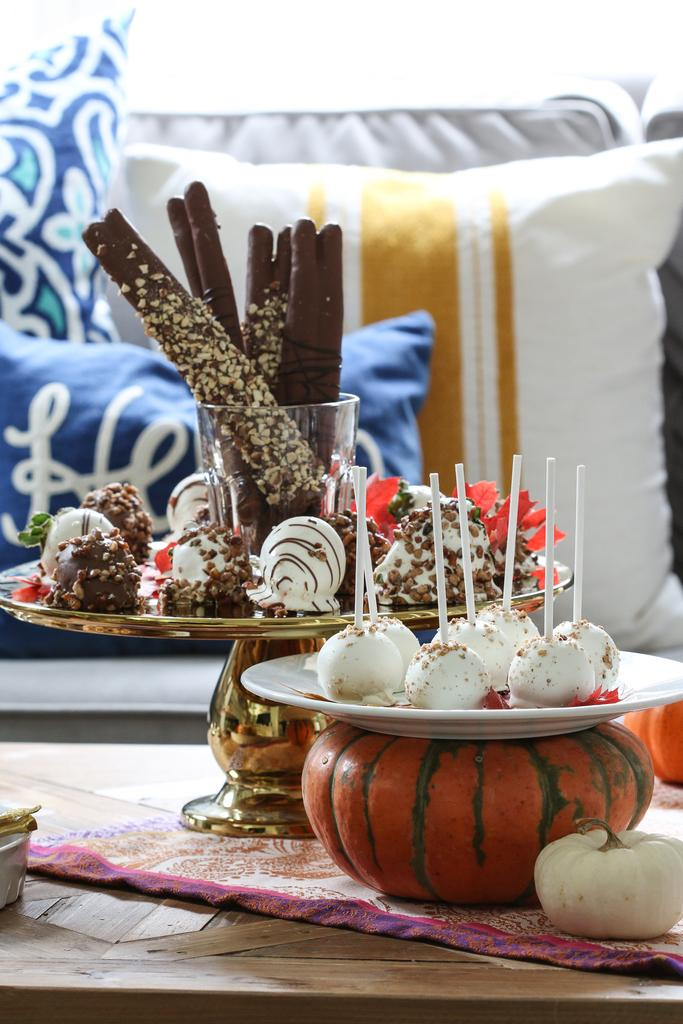What is present on the table in the image? There are food items on a table in the image. What other objects can be seen in the image besides the food items? There are pillows on a sofa in the image. Can you see any popcorn on the table in the image? There is no popcorn visible on the table in the image. Is the head of a person visible in the image? The image does not show any part of a person's head. 